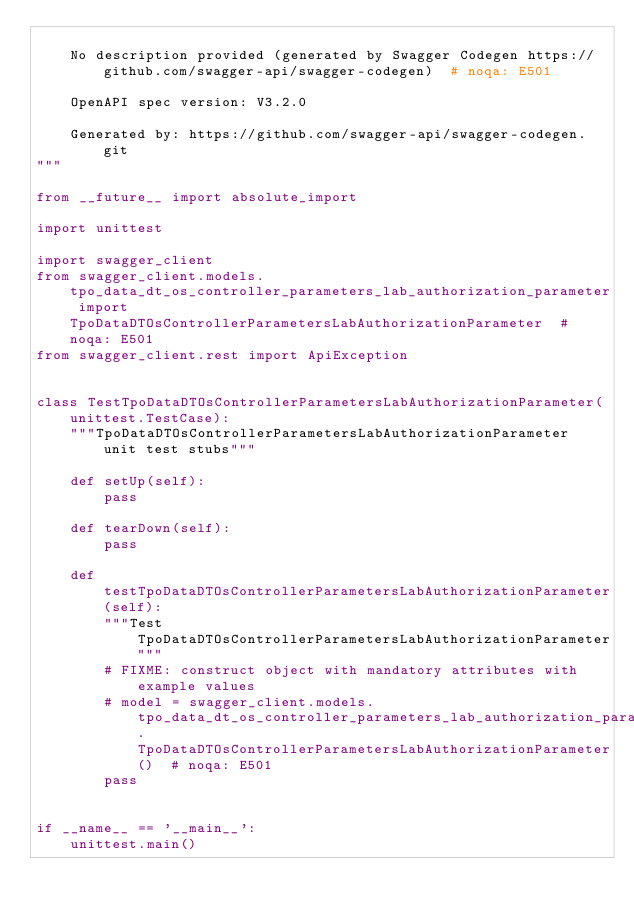Convert code to text. <code><loc_0><loc_0><loc_500><loc_500><_Python_>
    No description provided (generated by Swagger Codegen https://github.com/swagger-api/swagger-codegen)  # noqa: E501

    OpenAPI spec version: V3.2.0
    
    Generated by: https://github.com/swagger-api/swagger-codegen.git
"""

from __future__ import absolute_import

import unittest

import swagger_client
from swagger_client.models.tpo_data_dt_os_controller_parameters_lab_authorization_parameter import TpoDataDTOsControllerParametersLabAuthorizationParameter  # noqa: E501
from swagger_client.rest import ApiException


class TestTpoDataDTOsControllerParametersLabAuthorizationParameter(unittest.TestCase):
    """TpoDataDTOsControllerParametersLabAuthorizationParameter unit test stubs"""

    def setUp(self):
        pass

    def tearDown(self):
        pass

    def testTpoDataDTOsControllerParametersLabAuthorizationParameter(self):
        """Test TpoDataDTOsControllerParametersLabAuthorizationParameter"""
        # FIXME: construct object with mandatory attributes with example values
        # model = swagger_client.models.tpo_data_dt_os_controller_parameters_lab_authorization_parameter.TpoDataDTOsControllerParametersLabAuthorizationParameter()  # noqa: E501
        pass


if __name__ == '__main__':
    unittest.main()
</code> 